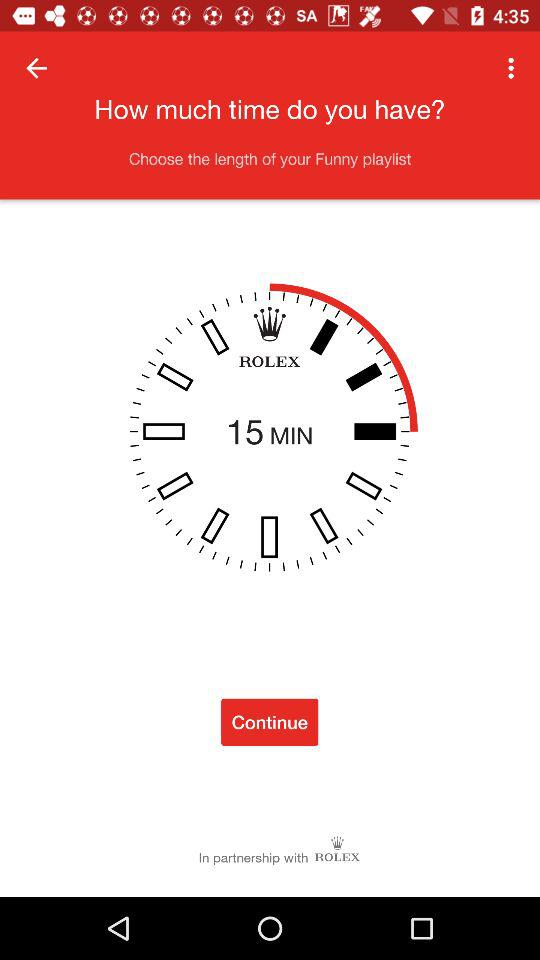What is the selected time duration? The selected time duration is 15 minutes. 